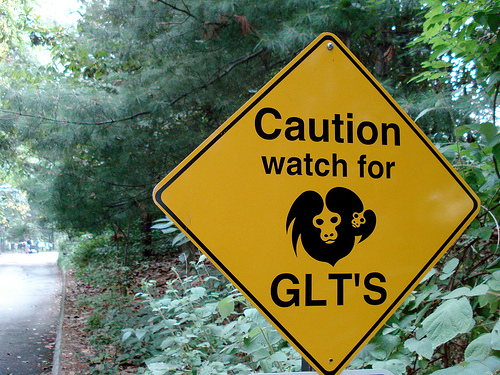<image>
Is there a sign board to the left of the plant? No. The sign board is not to the left of the plant. From this viewpoint, they have a different horizontal relationship. 